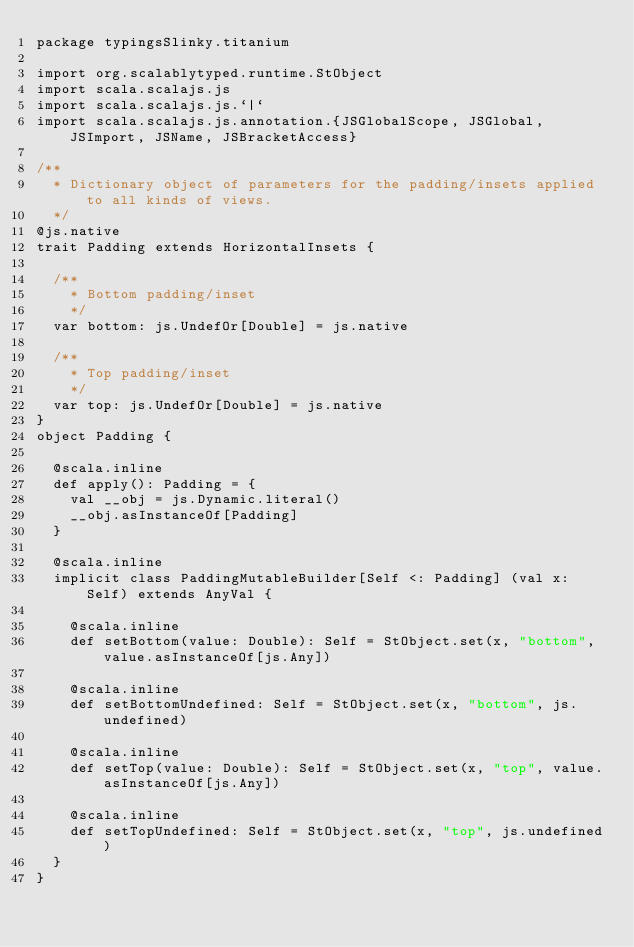<code> <loc_0><loc_0><loc_500><loc_500><_Scala_>package typingsSlinky.titanium

import org.scalablytyped.runtime.StObject
import scala.scalajs.js
import scala.scalajs.js.`|`
import scala.scalajs.js.annotation.{JSGlobalScope, JSGlobal, JSImport, JSName, JSBracketAccess}

/**
  * Dictionary object of parameters for the padding/insets applied to all kinds of views.
  */
@js.native
trait Padding extends HorizontalInsets {
  
  /**
    * Bottom padding/inset
    */
  var bottom: js.UndefOr[Double] = js.native
  
  /**
    * Top padding/inset
    */
  var top: js.UndefOr[Double] = js.native
}
object Padding {
  
  @scala.inline
  def apply(): Padding = {
    val __obj = js.Dynamic.literal()
    __obj.asInstanceOf[Padding]
  }
  
  @scala.inline
  implicit class PaddingMutableBuilder[Self <: Padding] (val x: Self) extends AnyVal {
    
    @scala.inline
    def setBottom(value: Double): Self = StObject.set(x, "bottom", value.asInstanceOf[js.Any])
    
    @scala.inline
    def setBottomUndefined: Self = StObject.set(x, "bottom", js.undefined)
    
    @scala.inline
    def setTop(value: Double): Self = StObject.set(x, "top", value.asInstanceOf[js.Any])
    
    @scala.inline
    def setTopUndefined: Self = StObject.set(x, "top", js.undefined)
  }
}
</code> 